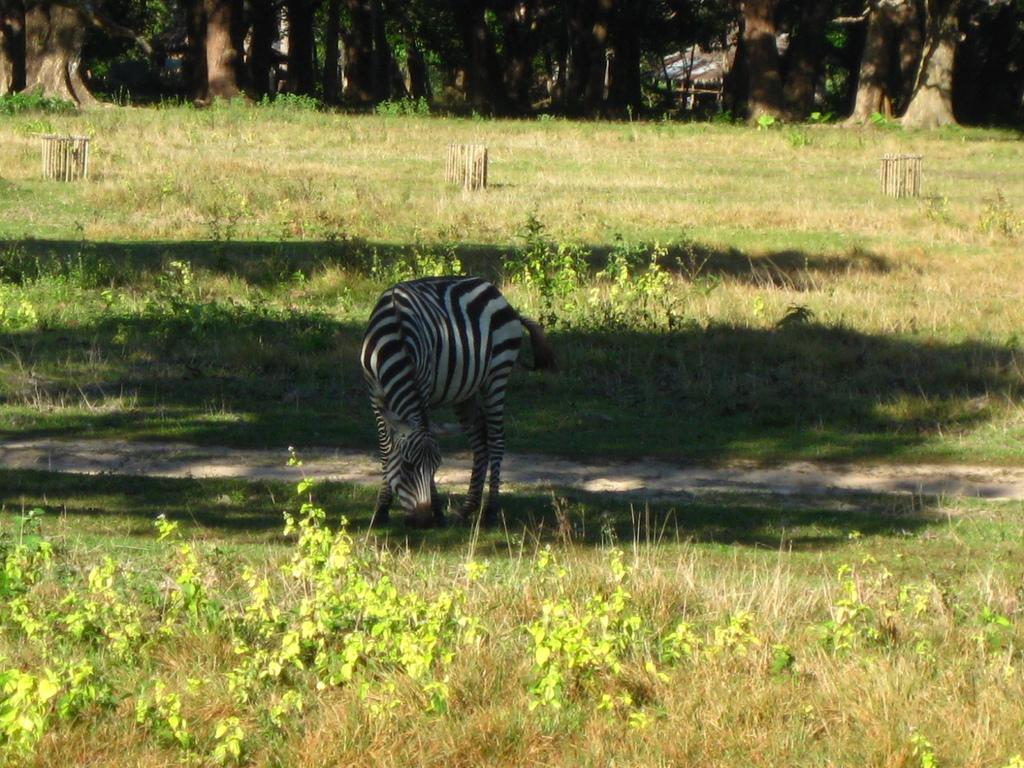What animal is the main subject of the image? There is a zebra in the image. What is the zebra doing in the image? The zebra is eating grass in the image. What type of vegetation is present on the ground? There are small plants and grass on the ground. What can be seen in the background of the image? There are many trees in the background. Where is the woman holding the baby in the crib in the image? There is no woman, baby, or crib present in the image; it features a zebra eating grass with trees in the background. 